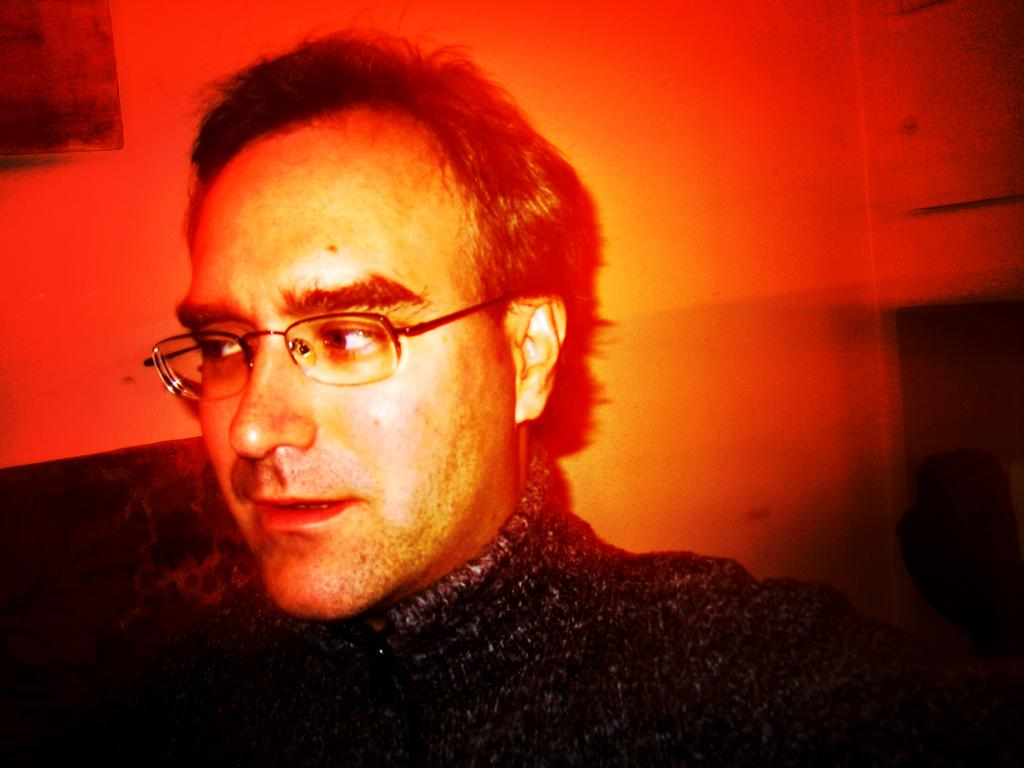What is the main subject of the image? There is a man in the image. What type of butter is the man using to look for ants in the image? There is no butter or ants present in the image, and the man is not using any butter to look for ants. 